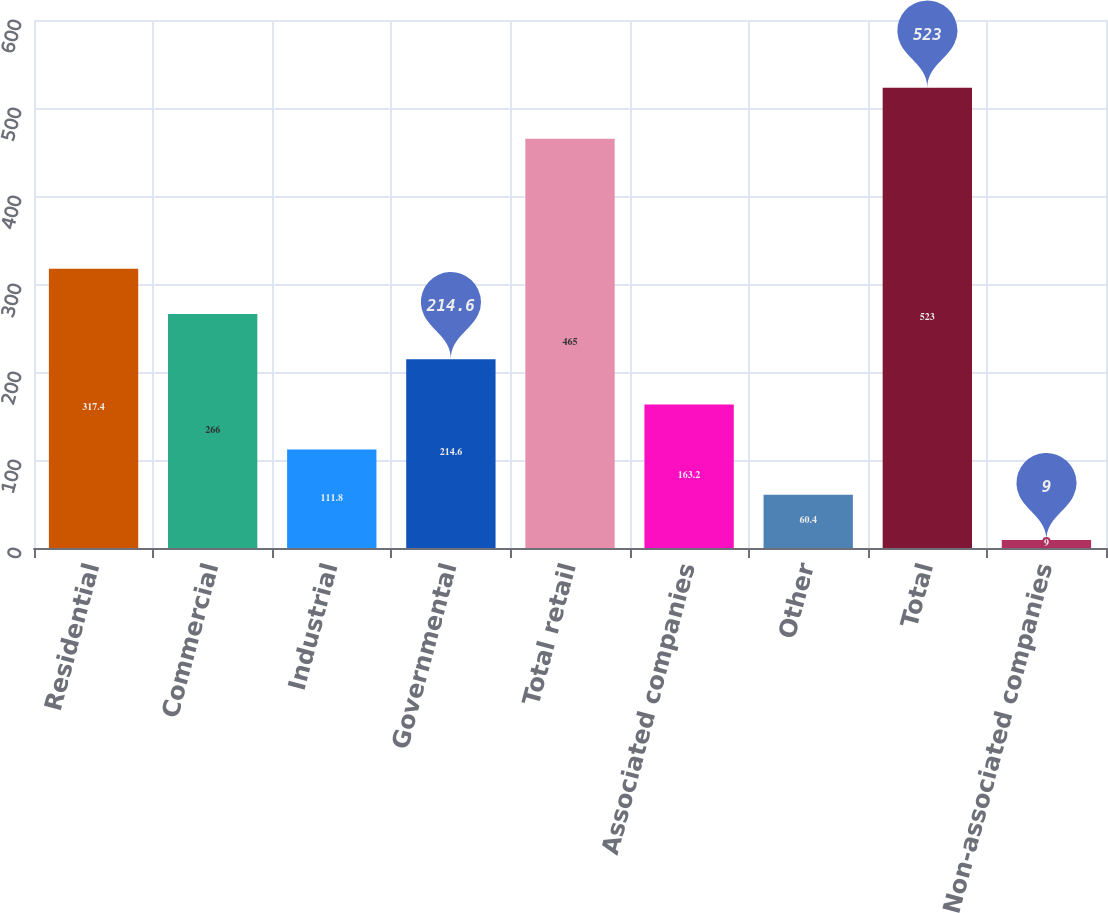Convert chart to OTSL. <chart><loc_0><loc_0><loc_500><loc_500><bar_chart><fcel>Residential<fcel>Commercial<fcel>Industrial<fcel>Governmental<fcel>Total retail<fcel>Associated companies<fcel>Other<fcel>Total<fcel>Non-associated companies<nl><fcel>317.4<fcel>266<fcel>111.8<fcel>214.6<fcel>465<fcel>163.2<fcel>60.4<fcel>523<fcel>9<nl></chart> 